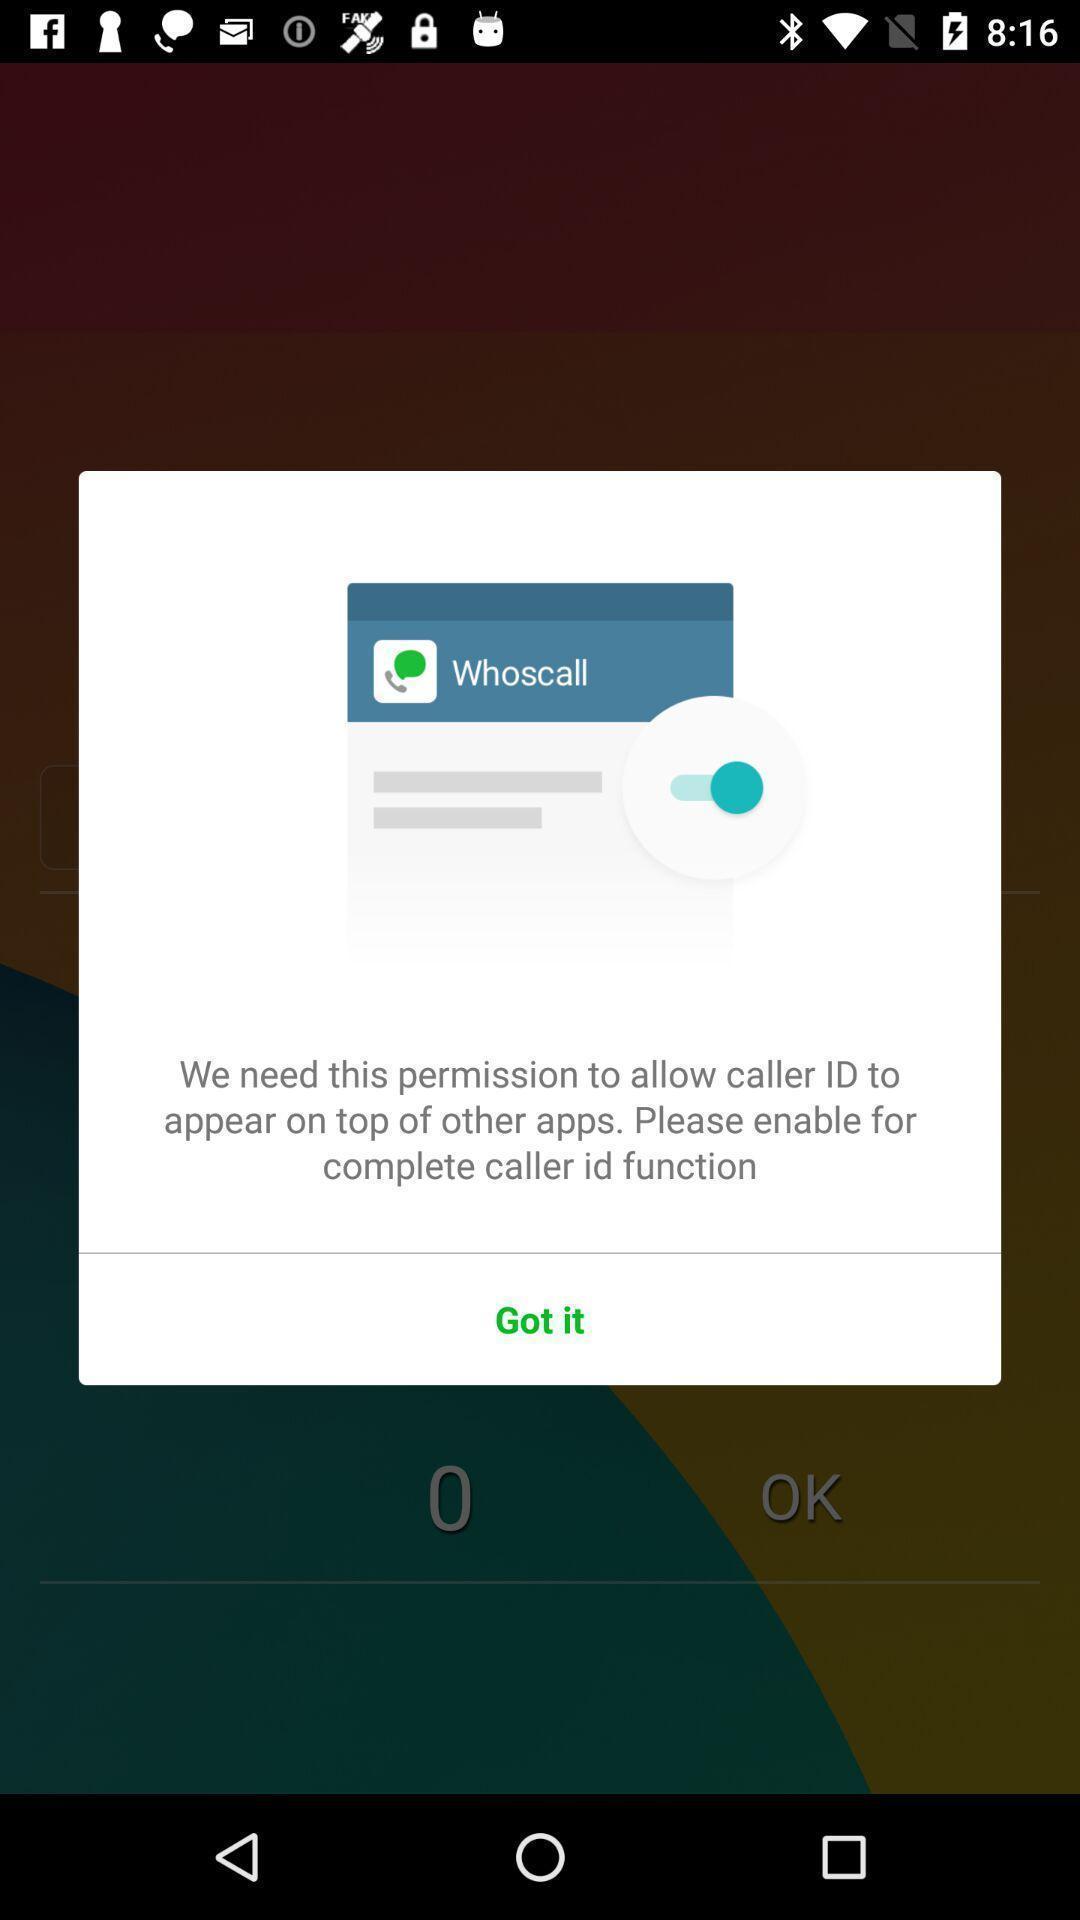What can you discern from this picture? Pop-up showing to allow caller id. 